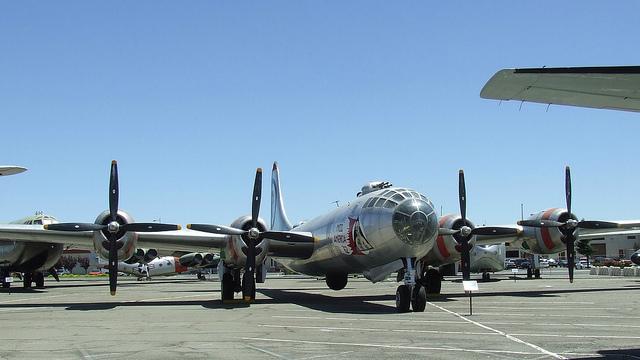Are these historical planes?
Concise answer only. Yes. How many propellers does the plane have?
Quick response, please. 4. How many propellers?
Write a very short answer. 4. Are the planes in motion?
Write a very short answer. No. 